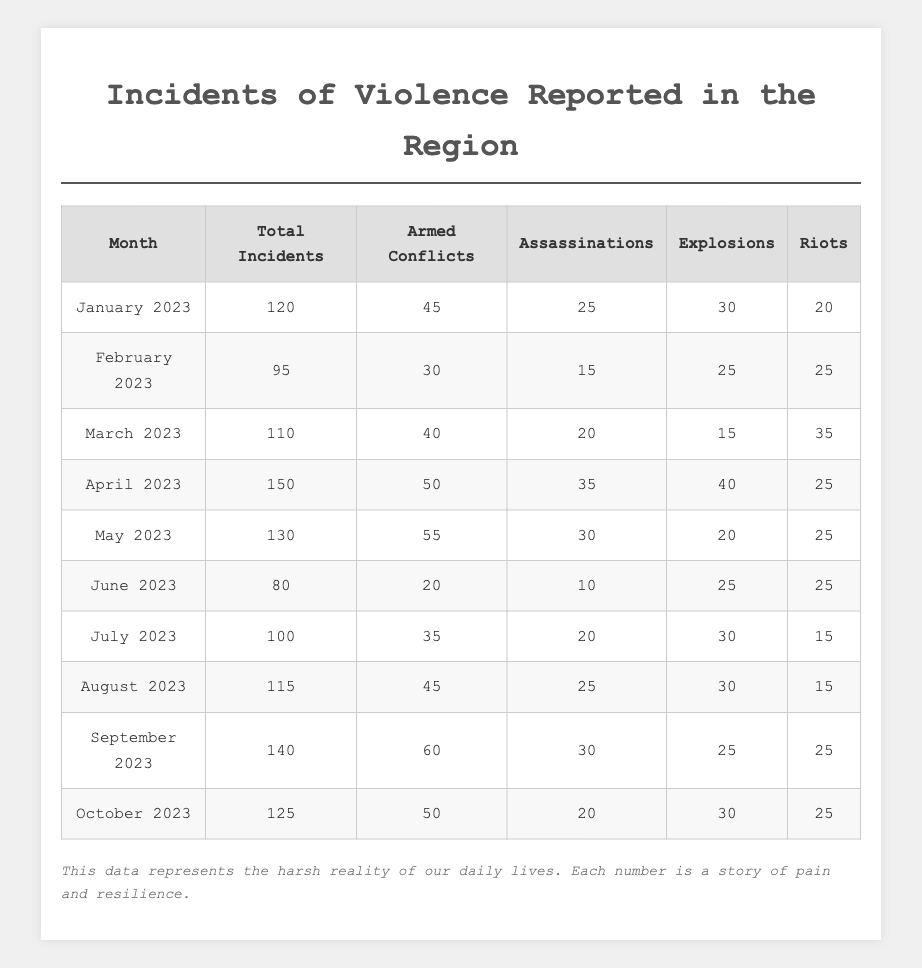What was the total number of incidents reported in April 2023? In April 2023, the table shows that the total incidents reported were 150.
Answer: 150 How many assassinations were recorded in February 2023? According to the table, February 2023 had 15 recorded assassinations.
Answer: 15 What is the total number of incidents from January to June 2023? Adding the total incidents for January (120), February (95), March (110), April (150), May (130), and June (80) gives a sum of 120 + 95 + 110 + 150 + 130 + 80 = 685.
Answer: 685 Which month had the highest reported armed conflicts? The month with the highest armed conflicts is September 2023 with 60 incidents reported.
Answer: September 2023 Were there more alarming events (assassinations, explosions) in July or August 2023? For July 2023, there were 20 assassinations and 30 explosions, totalling 50. In August 2023, there were 25 assassinations and 30 explosions, totalling 55. Thus, August 2023 had more alarming events.
Answer: August 2023 What is the average number of riots reported from January to October 2023? The total number of riots during this period is 20 + 25 + 35 + 25 + 25 + 25 + 15 + 15 + 25 + 25 =  275. Dividing by 10 months gives an average of 275/10 = 27.5.
Answer: 27.5 Did the total incidents decrease or increase from June to July 2023? In June 2023, there were 80 total incidents, and in July 2023, the incidents increased to 100. Therefore, there was an increase from June to July.
Answer: Increase Which month had the least total incidents reported? June 2023 reported the least with a total of 80 incidents.
Answer: June 2023 What is the difference in total incidents between the highest month and the lowest month? The highest month is April 2023 (150 incidents) and the lowest is June 2023 (80 incidents). The difference is 150 - 80 = 70.
Answer: 70 What percentage of total incidents in August 2023 were armed conflicts? In August 2023, there were 115 total incidents, with 45 being armed conflicts. The percentage is calculated as (45/115)*100 = 39.13%.
Answer: 39.13% 